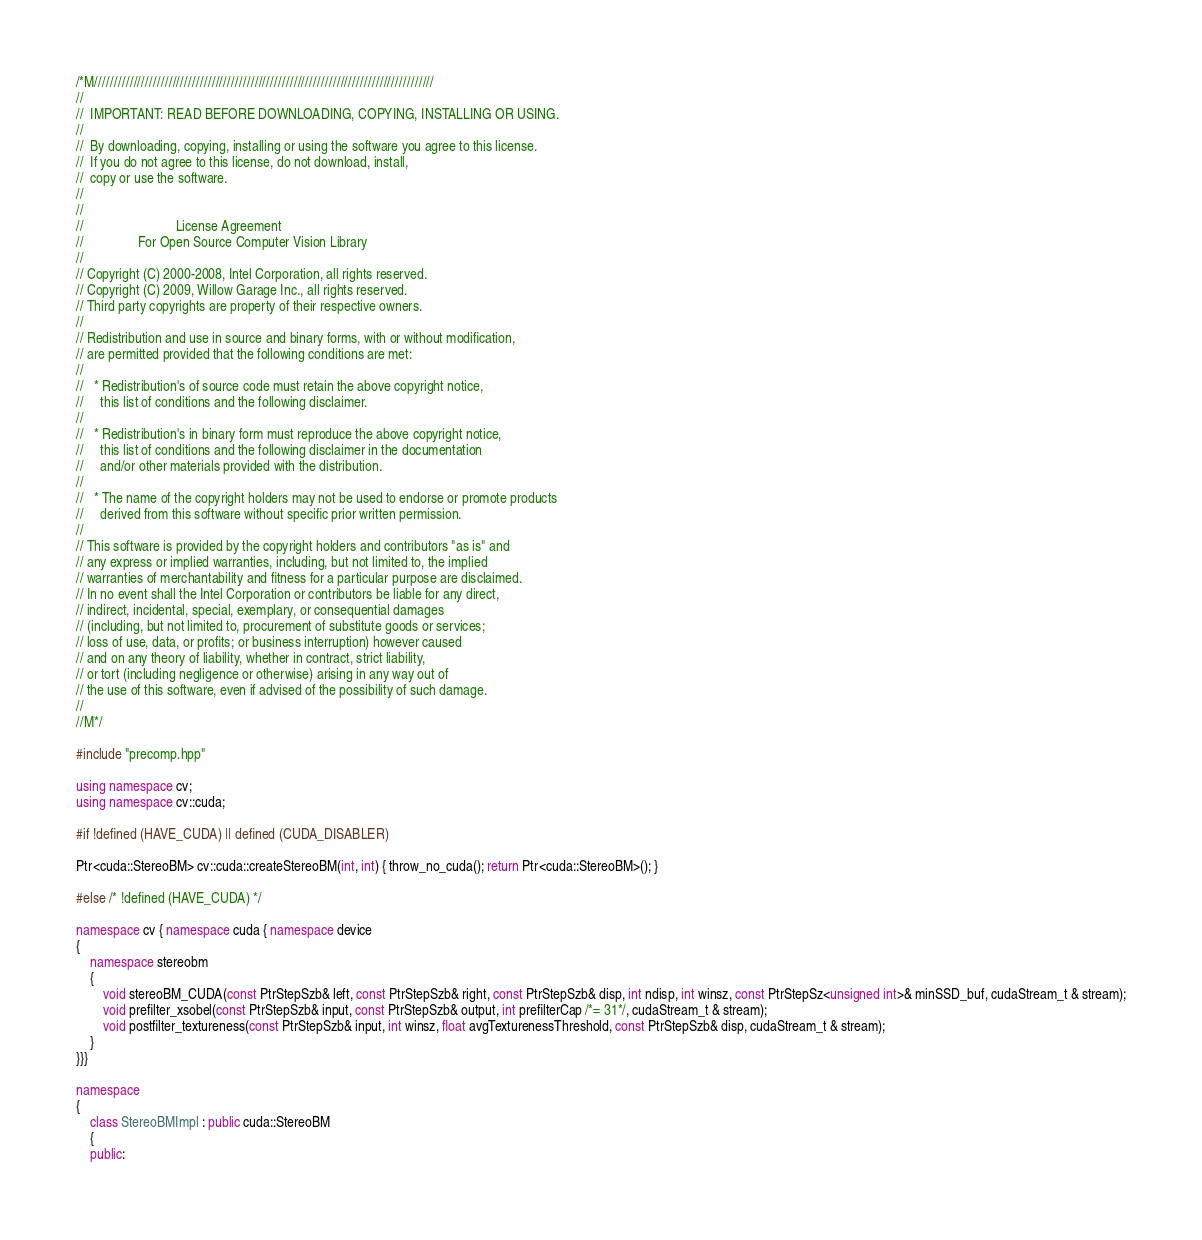<code> <loc_0><loc_0><loc_500><loc_500><_C++_>/*M///////////////////////////////////////////////////////////////////////////////////////
//
//  IMPORTANT: READ BEFORE DOWNLOADING, COPYING, INSTALLING OR USING.
//
//  By downloading, copying, installing or using the software you agree to this license.
//  If you do not agree to this license, do not download, install,
//  copy or use the software.
//
//
//                           License Agreement
//                For Open Source Computer Vision Library
//
// Copyright (C) 2000-2008, Intel Corporation, all rights reserved.
// Copyright (C) 2009, Willow Garage Inc., all rights reserved.
// Third party copyrights are property of their respective owners.
//
// Redistribution and use in source and binary forms, with or without modification,
// are permitted provided that the following conditions are met:
//
//   * Redistribution's of source code must retain the above copyright notice,
//     this list of conditions and the following disclaimer.
//
//   * Redistribution's in binary form must reproduce the above copyright notice,
//     this list of conditions and the following disclaimer in the documentation
//     and/or other materials provided with the distribution.
//
//   * The name of the copyright holders may not be used to endorse or promote products
//     derived from this software without specific prior written permission.
//
// This software is provided by the copyright holders and contributors "as is" and
// any express or implied warranties, including, but not limited to, the implied
// warranties of merchantability and fitness for a particular purpose are disclaimed.
// In no event shall the Intel Corporation or contributors be liable for any direct,
// indirect, incidental, special, exemplary, or consequential damages
// (including, but not limited to, procurement of substitute goods or services;
// loss of use, data, or profits; or business interruption) however caused
// and on any theory of liability, whether in contract, strict liability,
// or tort (including negligence or otherwise) arising in any way out of
// the use of this software, even if advised of the possibility of such damage.
//
//M*/

#include "precomp.hpp"

using namespace cv;
using namespace cv::cuda;

#if !defined (HAVE_CUDA) || defined (CUDA_DISABLER)

Ptr<cuda::StereoBM> cv::cuda::createStereoBM(int, int) { throw_no_cuda(); return Ptr<cuda::StereoBM>(); }

#else /* !defined (HAVE_CUDA) */

namespace cv { namespace cuda { namespace device
{
    namespace stereobm
    {
        void stereoBM_CUDA(const PtrStepSzb& left, const PtrStepSzb& right, const PtrStepSzb& disp, int ndisp, int winsz, const PtrStepSz<unsigned int>& minSSD_buf, cudaStream_t & stream);
        void prefilter_xsobel(const PtrStepSzb& input, const PtrStepSzb& output, int prefilterCap /*= 31*/, cudaStream_t & stream);
        void postfilter_textureness(const PtrStepSzb& input, int winsz, float avgTexturenessThreshold, const PtrStepSzb& disp, cudaStream_t & stream);
    }
}}}

namespace
{
    class StereoBMImpl : public cuda::StereoBM
    {
    public:</code> 